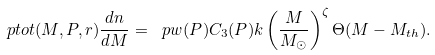Convert formula to latex. <formula><loc_0><loc_0><loc_500><loc_500>\ p t o t ( M , P , r ) \frac { d n } { d M } = \ p w ( P ) C _ { 3 } ( P ) k \left ( \frac { M } { M _ { \odot } } \right ) ^ { \zeta } \Theta ( M - M _ { t h } ) .</formula> 